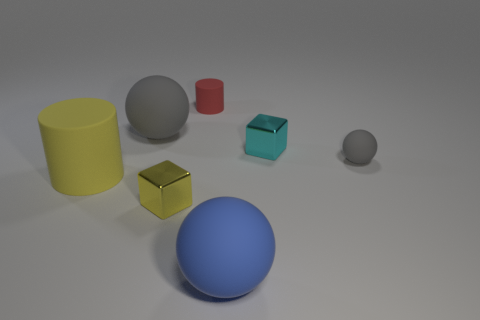There is a tiny rubber object that is right of the shiny cube that is behind the rubber cylinder that is to the left of the yellow metal cube; what is its shape? sphere 